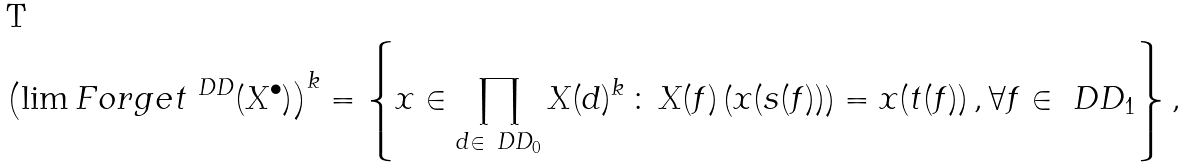Convert formula to latex. <formula><loc_0><loc_0><loc_500><loc_500>\left ( \lim F o r g e t ^ { \ D D } ( X ^ { \bullet } ) \right ) ^ { k } = \left \{ x \in \prod _ { d \in \ D D _ { 0 } } X ( d ) ^ { k } \, \colon \, X ( f ) \left ( x ( s ( f ) ) \right ) = x ( t ( f ) ) \, , \forall f \in \ D D _ { 1 } \right \} ,</formula> 